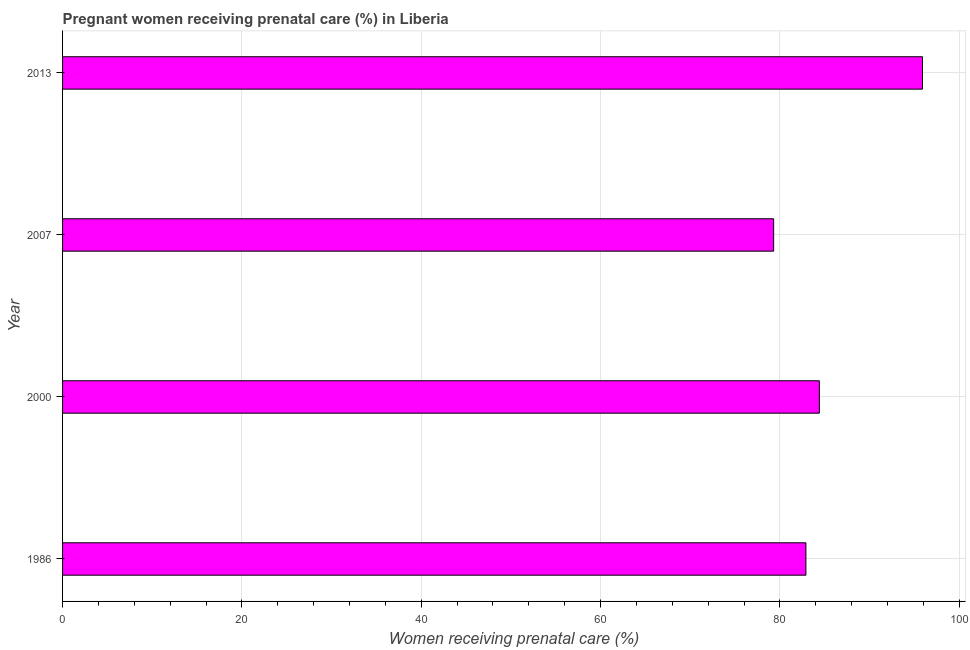Does the graph contain grids?
Provide a short and direct response. Yes. What is the title of the graph?
Your answer should be compact. Pregnant women receiving prenatal care (%) in Liberia. What is the label or title of the X-axis?
Provide a succinct answer. Women receiving prenatal care (%). What is the percentage of pregnant women receiving prenatal care in 1986?
Offer a terse response. 82.9. Across all years, what is the maximum percentage of pregnant women receiving prenatal care?
Offer a terse response. 95.9. Across all years, what is the minimum percentage of pregnant women receiving prenatal care?
Offer a very short reply. 79.3. In which year was the percentage of pregnant women receiving prenatal care maximum?
Your answer should be very brief. 2013. In which year was the percentage of pregnant women receiving prenatal care minimum?
Provide a short and direct response. 2007. What is the sum of the percentage of pregnant women receiving prenatal care?
Ensure brevity in your answer.  342.5. What is the average percentage of pregnant women receiving prenatal care per year?
Offer a terse response. 85.62. What is the median percentage of pregnant women receiving prenatal care?
Offer a terse response. 83.65. Do a majority of the years between 2000 and 2013 (inclusive) have percentage of pregnant women receiving prenatal care greater than 88 %?
Provide a short and direct response. No. What is the ratio of the percentage of pregnant women receiving prenatal care in 1986 to that in 2000?
Provide a succinct answer. 0.98. What is the difference between the highest and the second highest percentage of pregnant women receiving prenatal care?
Offer a terse response. 11.5. What is the difference between the highest and the lowest percentage of pregnant women receiving prenatal care?
Make the answer very short. 16.6. Are all the bars in the graph horizontal?
Offer a terse response. Yes. What is the Women receiving prenatal care (%) of 1986?
Your response must be concise. 82.9. What is the Women receiving prenatal care (%) of 2000?
Your response must be concise. 84.4. What is the Women receiving prenatal care (%) in 2007?
Make the answer very short. 79.3. What is the Women receiving prenatal care (%) of 2013?
Your response must be concise. 95.9. What is the difference between the Women receiving prenatal care (%) in 1986 and 2007?
Provide a succinct answer. 3.6. What is the difference between the Women receiving prenatal care (%) in 1986 and 2013?
Ensure brevity in your answer.  -13. What is the difference between the Women receiving prenatal care (%) in 2000 and 2013?
Your answer should be very brief. -11.5. What is the difference between the Women receiving prenatal care (%) in 2007 and 2013?
Your answer should be compact. -16.6. What is the ratio of the Women receiving prenatal care (%) in 1986 to that in 2000?
Give a very brief answer. 0.98. What is the ratio of the Women receiving prenatal care (%) in 1986 to that in 2007?
Offer a very short reply. 1.04. What is the ratio of the Women receiving prenatal care (%) in 1986 to that in 2013?
Keep it short and to the point. 0.86. What is the ratio of the Women receiving prenatal care (%) in 2000 to that in 2007?
Your answer should be very brief. 1.06. What is the ratio of the Women receiving prenatal care (%) in 2000 to that in 2013?
Your answer should be compact. 0.88. What is the ratio of the Women receiving prenatal care (%) in 2007 to that in 2013?
Offer a terse response. 0.83. 